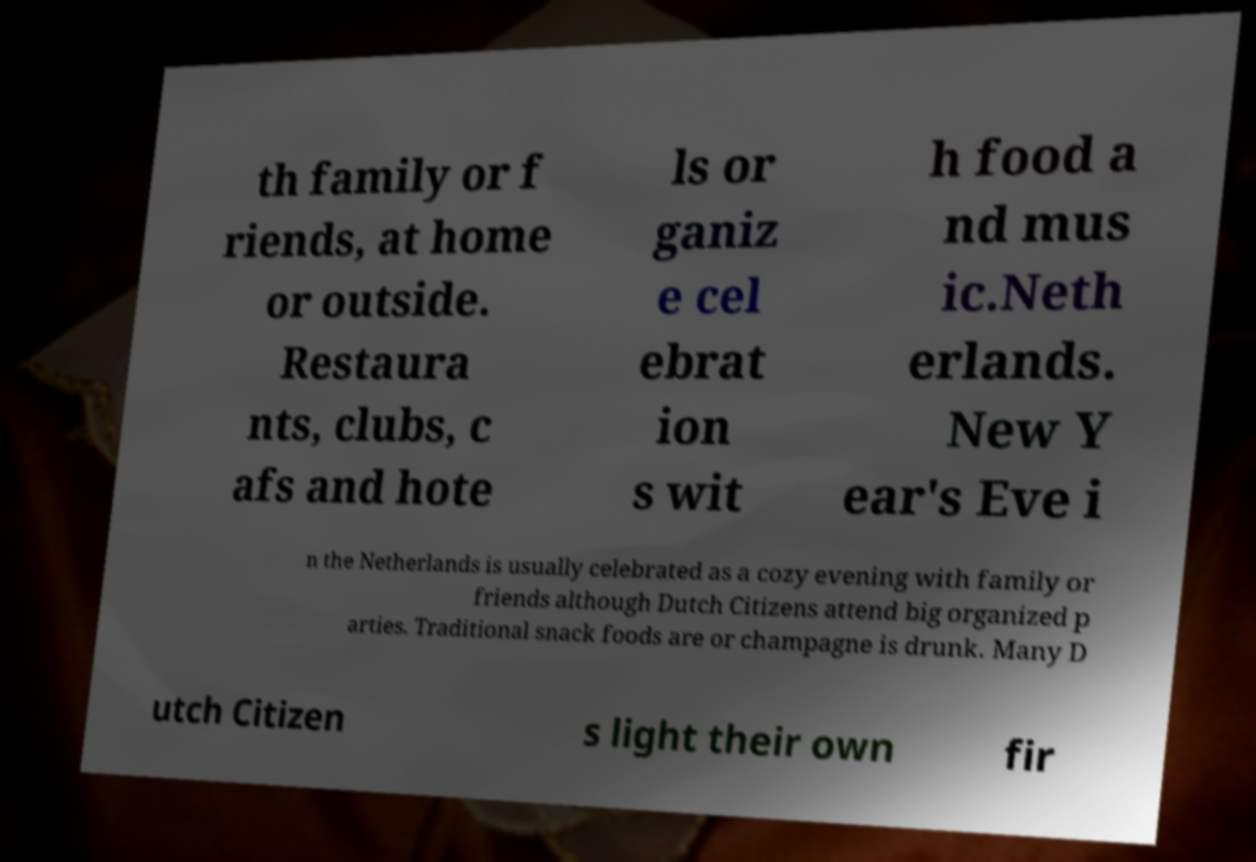For documentation purposes, I need the text within this image transcribed. Could you provide that? th family or f riends, at home or outside. Restaura nts, clubs, c afs and hote ls or ganiz e cel ebrat ion s wit h food a nd mus ic.Neth erlands. New Y ear's Eve i n the Netherlands is usually celebrated as a cozy evening with family or friends although Dutch Citizens attend big organized p arties. Traditional snack foods are or champagne is drunk. Many D utch Citizen s light their own fir 